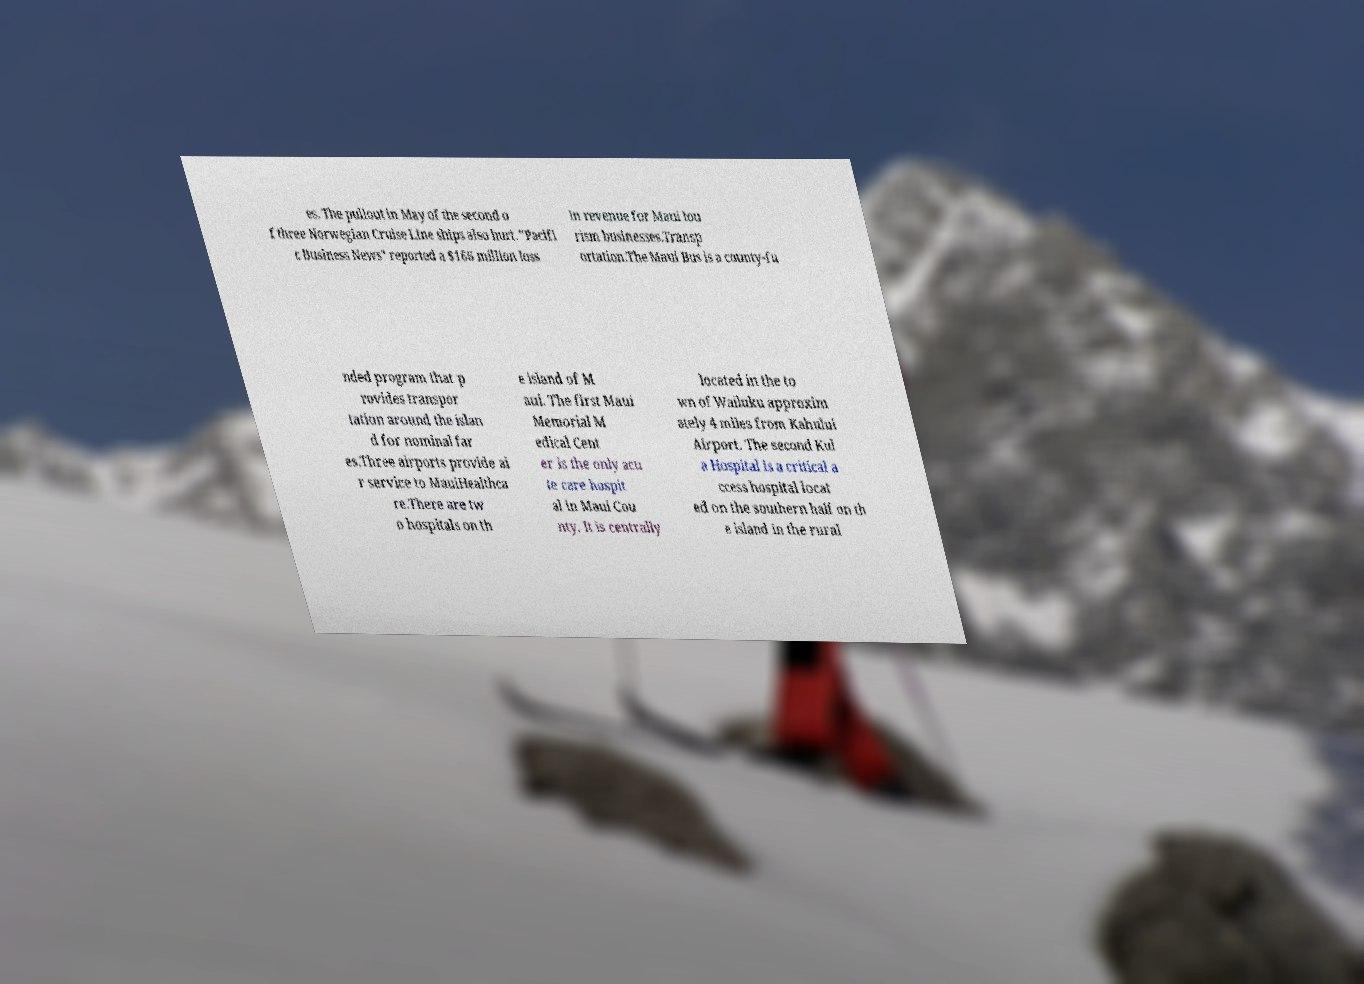Please read and relay the text visible in this image. What does it say? es. The pullout in May of the second o f three Norwegian Cruise Line ships also hurt. "Pacifi c Business News" reported a $166 million loss in revenue for Maui tou rism businesses.Transp ortation.The Maui Bus is a county-fu nded program that p rovides transpor tation around the islan d for nominal far es.Three airports provide ai r service to MauiHealthca re.There are tw o hospitals on th e island of M aui. The first Maui Memorial M edical Cent er is the only acu te care hospit al in Maui Cou nty. It is centrally located in the to wn of Wailuku approxim ately 4 miles from Kahului Airport. The second Kul a Hospital is a critical a ccess hospital locat ed on the southern half on th e island in the rural 